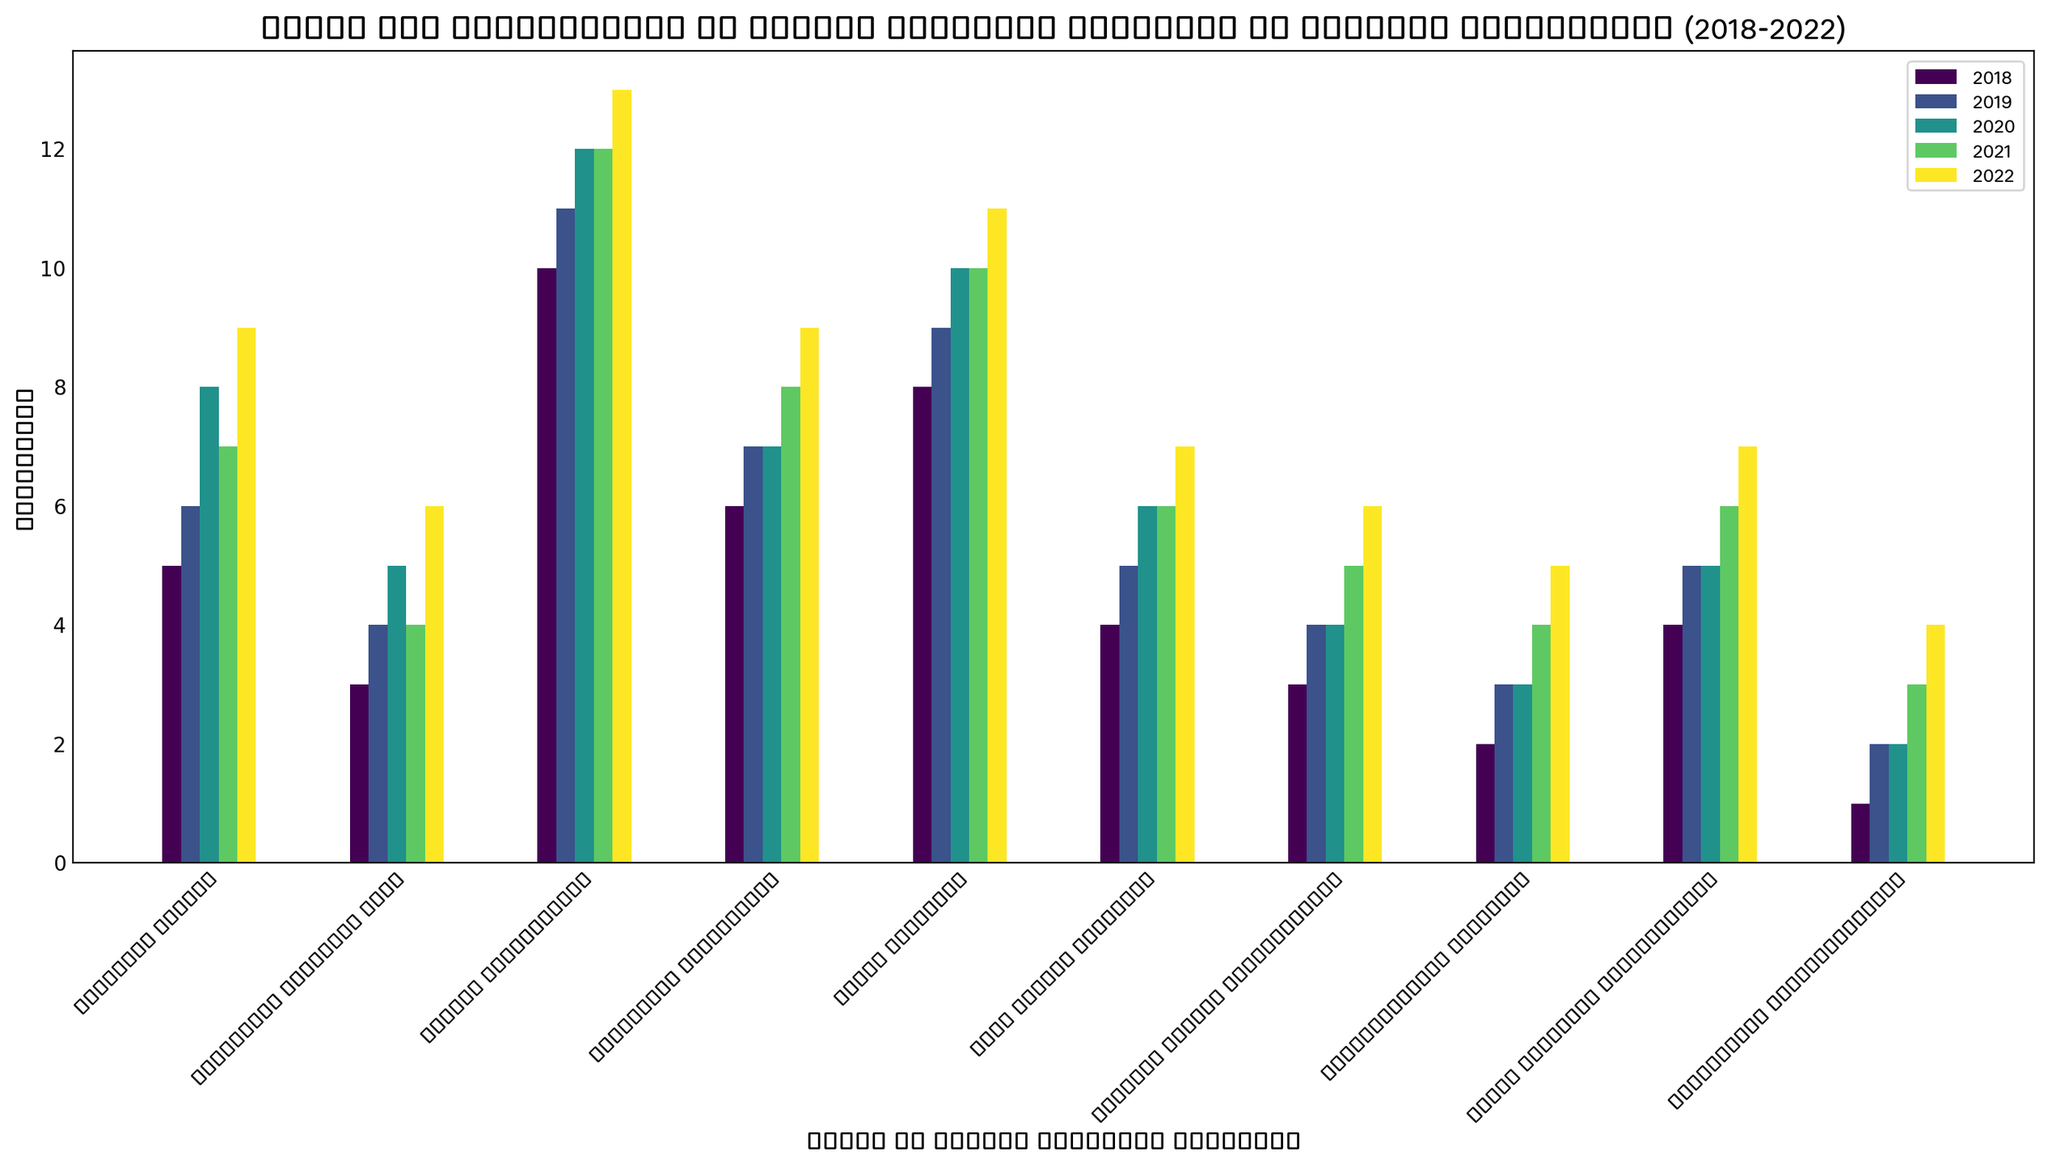What type of safety protocol upgrade has the highest frequency in 2022? The bar for 'System Inspections' is the tallest in 2022, indicating the highest frequency.
Answer: System Inspections How many total 'Cooling System Enhancements' were performed between 2018 and 2022? Sum the frequencies for 'Cooling System Enhancements' from 2018 to 2022: 3 + 4 + 4 + 5 + 6 = 22.
Answer: 22 Which year saw the highest number of 'Staff Training' upgrades? Compare the heights of the bars for 'Staff Training' across all years. The highest bar is in 2022.
Answer: 2022 Is the frequency of 'Cybersecurity Measures' in 2019 greater than in 2020? Compare the heights of the bars for 'Cybersecurity Measures' in 2019 and 2020. The bar for 2019 is slightly taller.
Answer: Yes What is the average number of 'Radiation Monitoring' upgrades over the five years? Sum the frequencies of 'Radiation Monitoring' upgrades from 2018 to 2022 and divide by 5: (6 + 7 + 7 + 8 + 9)/5 = 37/5 = 7.4.
Answer: 7.4 Did the frequency of 'Structural Reinforcements' upgrades increase every year? Inspect the trend for 'Structural Reinforcements' from 2018 to 2022. The bars increase in height sequentially: 1, 2, 2, 3, 4.
Answer: Yes Which type of safety protocol upgrade had the lowest frequency in 2018? Identify the shortest bar for 2018. The shortest bar represents 'Structural Reinforcements'.
Answer: Structural Reinforcements By how much did the frequency of 'Fire Safety Upgrades' increase from 2018 to 2022? Subtract the frequency in 2018 from the frequency in 2022: 7 - 4 = 3.
Answer: 3 Compare the 2020 frequencies of 'System Inspections' and 'Emergency Response Plan'. Which one is higher and by how much? The bars indicate 12 for 'System Inspections' and 5 for 'Emergency Response Plan'. The difference is 12 - 5.
Answer: System Inspections by 7 What is the total count of 'Security Drills' and 'Waste Disposal Improvements' for the year 2021? Add the frequencies for 'Security Drills' and 'Waste Disposal Improvements' for 2021: 7 + 6 = 13.
Answer: 13 